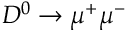Convert formula to latex. <formula><loc_0><loc_0><loc_500><loc_500>D ^ { 0 } \to \mu ^ { + } \mu ^ { - }</formula> 